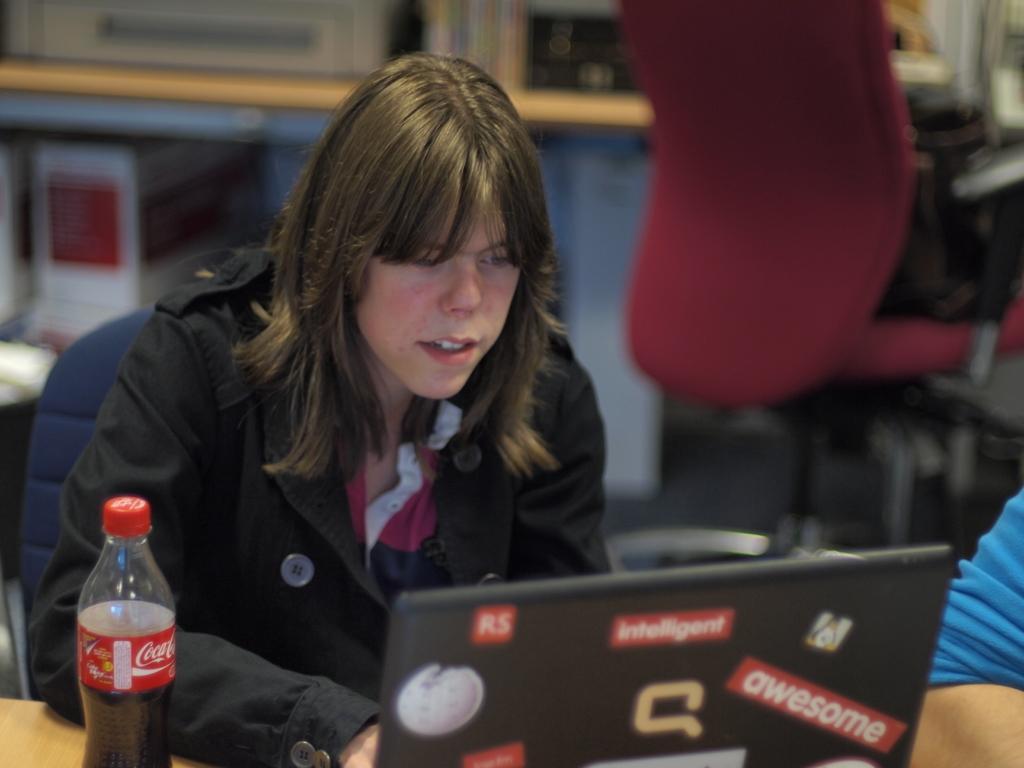Can you describe this image briefly? There is a woman sitting in the chair, in front of a table. she is wearing a black dress. On the table there is a laptop and a coke bottle. Behind her there is another chair and table, which was blurred. And the woman is looking into the laptop. 